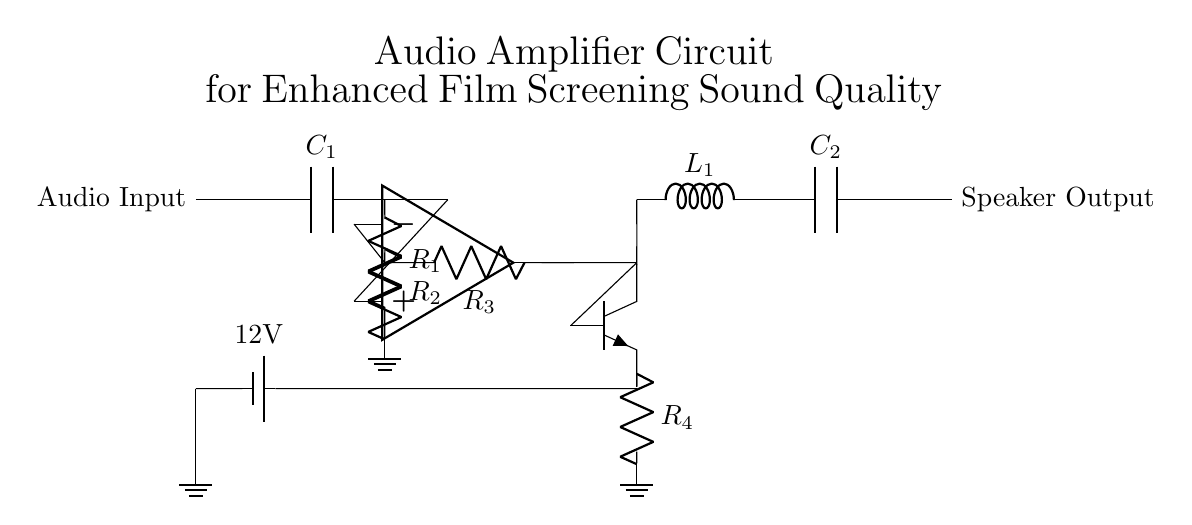What type of amplifier is used in the circuit? The circuit employs an operational amplifier in the pre-amplifier stage, which is designed to enhance the audio signal.
Answer: operational amplifier What is the value of the input capacitor? The circuit diagram indicates that the input capacitor is labeled as C1, but it does not provide a numerical value. Therefore, we can't specify its value based on the diagram alone.
Answer: unspecified How many resistors are present in the circuit? The circuit has four resistors: R1, R2, R3, and R4, as indicated by the labels on the components.
Answer: four What is the purpose of the inductor in this circuit? The inductor, labeled L1, is typically used for filtering and can help in shaping the frequency response of the output to the speaker, improving sound quality.
Answer: filtering Which component connects the audio input to the circuit? The component connecting the audio input to the circuit is the capacitor C1, which acts as a coupling device to pass the audio signal while blocking DC levels.
Answer: capacitor What is the power supply voltage in this circuit? The power supply voltage is specified as 12V, as indicated by the label next to the battery in the diagram.
Answer: 12V Which component is responsible for driving the speaker output? The final output from the power amplifier stage feeds into the capacitor C2, which then connects to the speaker output, suggesting that C2 shapes the final audio signal delivered.
Answer: capacitor C2 